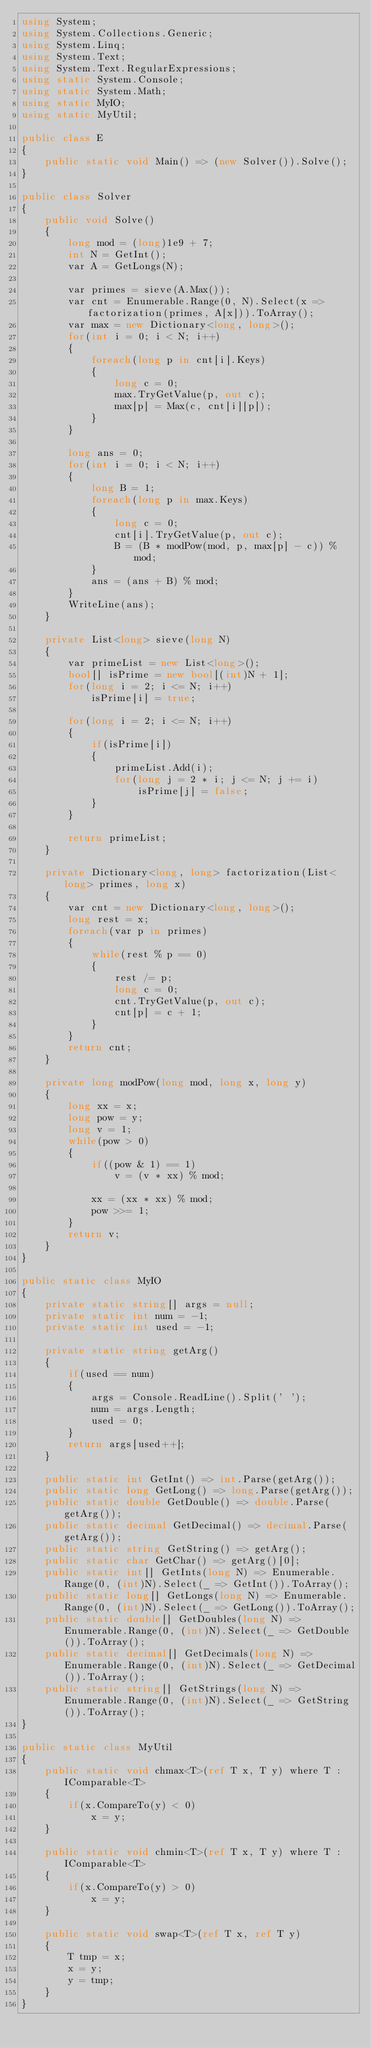<code> <loc_0><loc_0><loc_500><loc_500><_C#_>using System;
using System.Collections.Generic;
using System.Linq;
using System.Text;
using System.Text.RegularExpressions;
using static System.Console;
using static System.Math;
using static MyIO;
using static MyUtil;

public class E
{
	public static void Main() => (new Solver()).Solve();
}

public class Solver
{
	public void Solve()
	{
		long mod = (long)1e9 + 7;
		int N = GetInt();
		var A = GetLongs(N);

		var primes = sieve(A.Max());
		var cnt = Enumerable.Range(0, N).Select(x => factorization(primes, A[x])).ToArray();
		var max = new Dictionary<long, long>();
		for(int i = 0; i < N; i++)
		{
			foreach(long p in cnt[i].Keys)
			{
				long c = 0;
				max.TryGetValue(p, out c);
				max[p] = Max(c, cnt[i][p]);
			}
		}

		long ans = 0;
		for(int i = 0; i < N; i++)
		{
			long B = 1;
			foreach(long p in max.Keys)
			{
				long c = 0;
				cnt[i].TryGetValue(p, out c);
				B = (B * modPow(mod, p, max[p] - c)) % mod;
			}
			ans = (ans + B) % mod;
		}
		WriteLine(ans);
	}

	private List<long> sieve(long N)
	{
		var primeList = new List<long>();
		bool[] isPrime = new bool[(int)N + 1];
		for(long i = 2; i <= N; i++)
			isPrime[i] = true;

		for(long i = 2; i <= N; i++)
		{
			if(isPrime[i])
			{
				primeList.Add(i);
				for(long j = 2 * i; j <= N; j += i)
					isPrime[j] = false;
			}
		}

		return primeList;
	}

	private Dictionary<long, long> factorization(List<long> primes, long x)
	{
		var cnt = new Dictionary<long, long>();
		long rest = x;
		foreach(var p in primes)
		{
			while(rest % p == 0)
			{
				rest /= p;
				long c = 0;
				cnt.TryGetValue(p, out c);
				cnt[p] = c + 1;
			}
		}
		return cnt;
	}

	private long modPow(long mod, long x, long y)
	{
		long xx = x;
		long pow = y;
		long v = 1;
		while(pow > 0)
		{
			if((pow & 1) == 1)
				v = (v * xx) % mod;

			xx = (xx * xx) % mod;
			pow >>= 1;
		}
		return v;
	}
}

public static class MyIO
{
	private static string[] args = null;
	private static int num = -1;
	private static int used = -1;

	private static string getArg()
	{
		if(used == num)
		{
			args = Console.ReadLine().Split(' ');
			num = args.Length;
			used = 0;
		}
		return args[used++];
	}

	public static int GetInt() => int.Parse(getArg());
	public static long GetLong() => long.Parse(getArg());
	public static double GetDouble() => double.Parse(getArg());
	public static decimal GetDecimal() => decimal.Parse(getArg());
	public static string GetString() => getArg();
	public static char GetChar() => getArg()[0];
	public static int[] GetInts(long N) => Enumerable.Range(0, (int)N).Select(_ => GetInt()).ToArray();
	public static long[] GetLongs(long N) => Enumerable.Range(0, (int)N).Select(_ => GetLong()).ToArray();
	public static double[] GetDoubles(long N) => Enumerable.Range(0, (int)N).Select(_ => GetDouble()).ToArray();
	public static decimal[] GetDecimals(long N) => Enumerable.Range(0, (int)N).Select(_ => GetDecimal()).ToArray();
	public static string[] GetStrings(long N) => Enumerable.Range(0, (int)N).Select(_ => GetString()).ToArray();
}

public static class MyUtil
{
	public static void chmax<T>(ref T x, T y) where T : IComparable<T>
	{
		if(x.CompareTo(y) < 0)
			x = y;
	}

	public static void chmin<T>(ref T x, T y) where T : IComparable<T>
	{
		if(x.CompareTo(y) > 0)
			x = y;
	}

	public static void swap<T>(ref T x, ref T y)
	{
		T tmp = x;
		x = y;
		y = tmp;
	}
}</code> 